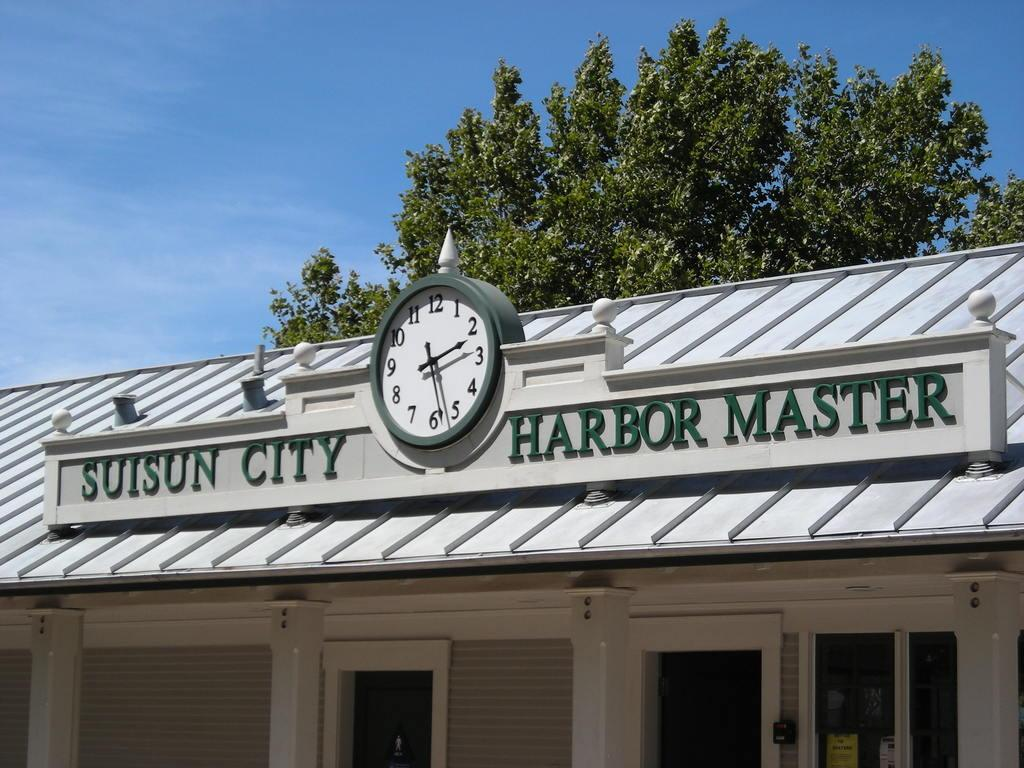<image>
Give a short and clear explanation of the subsequent image. Suisun City Harbor Master building with a clock in the middle 